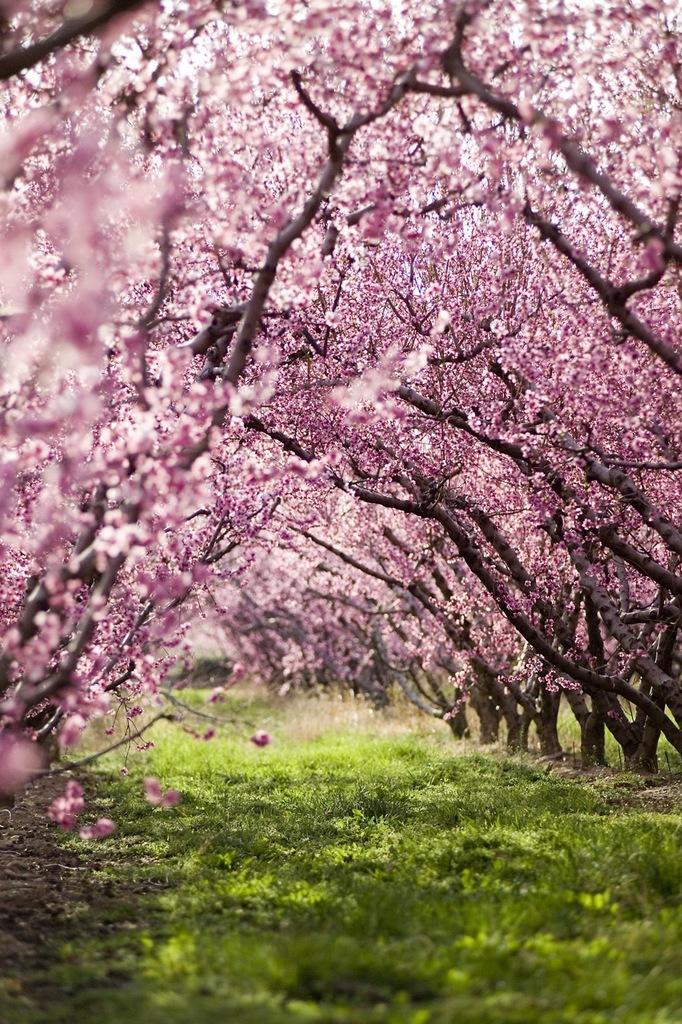Please provide a concise description of this image. In the middle there is grass. In this picture we can see trees, the trees are in purple color. 